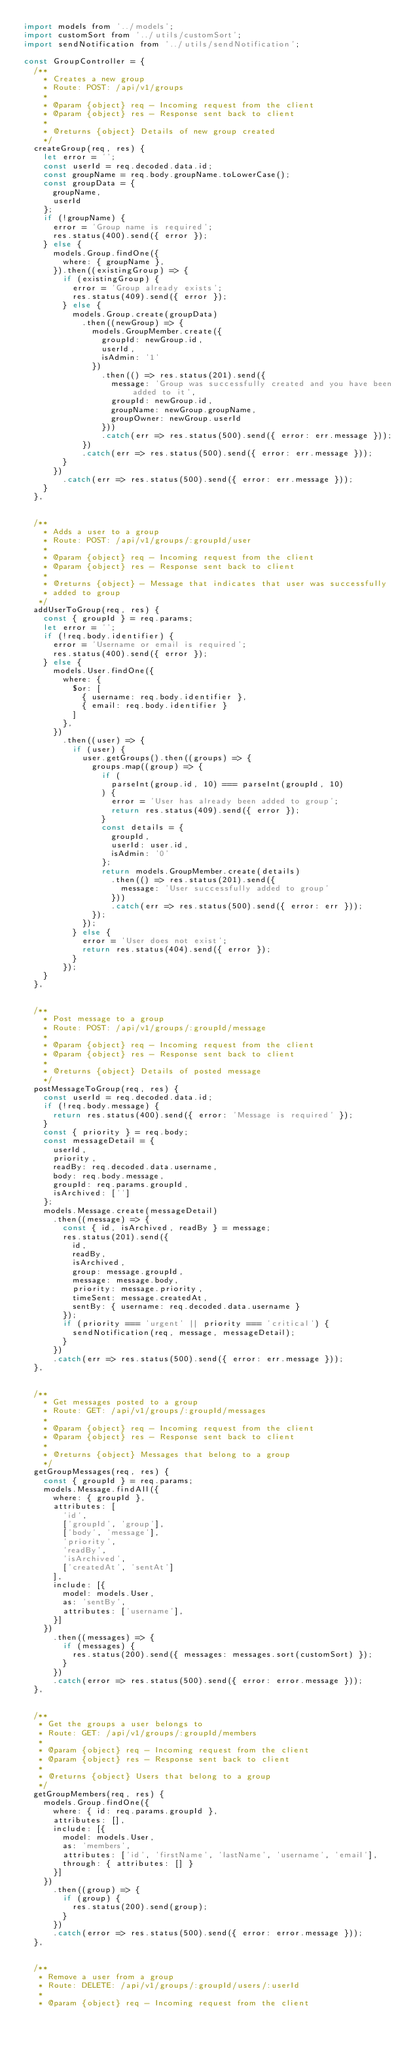<code> <loc_0><loc_0><loc_500><loc_500><_JavaScript_>import models from '../models';
import customSort from '../utils/customSort';
import sendNotification from '../utils/sendNotification';

const GroupController = {
  /**
    * Creates a new group
    * Route: POST: /api/v1/groups
    *
    * @param {object} req - Incoming request from the client
    * @param {object} res - Response sent back to client
    *
    * @returns {object} Details of new group created
    */
  createGroup(req, res) {
    let error = '';
    const userId = req.decoded.data.id;
    const groupName = req.body.groupName.toLowerCase();
    const groupData = {
      groupName,
      userId
    };
    if (!groupName) {
      error = 'Group name is required';
      res.status(400).send({ error });
    } else {
      models.Group.findOne({
        where: { groupName },
      }).then((existingGroup) => {
        if (existingGroup) {
          error = 'Group already exists';
          res.status(409).send({ error });
        } else {
          models.Group.create(groupData)
            .then((newGroup) => {
              models.GroupMember.create({
                groupId: newGroup.id,
                userId,
                isAdmin: '1'
              })
                .then(() => res.status(201).send({
                  message: 'Group was successfully created and you have been added to it',
                  groupId: newGroup.id,
                  groupName: newGroup.groupName,
                  groupOwner: newGroup.userId
                }))
                .catch(err => res.status(500).send({ error: err.message }));
            })
            .catch(err => res.status(500).send({ error: err.message }));
        }
      })
        .catch(err => res.status(500).send({ error: err.message }));
    }
  },


  /**
    * Adds a user to a group
    * Route: POST: /api/v1/groups/:groupId/user
    *
    * @param {object} req - Incoming request from the client
    * @param {object} res - Response sent back to client
    *
    * @returns {object} - Message that indicates that user was successfully
    * added to group
   */
  addUserToGroup(req, res) {
    const { groupId } = req.params;
    let error = '';
    if (!req.body.identifier) {
      error = 'Username or email is required';
      res.status(400).send({ error });
    } else {
      models.User.findOne({
        where: {
          $or: [
            { username: req.body.identifier },
            { email: req.body.identifier }
          ]
        },
      })
        .then((user) => {
          if (user) {
            user.getGroups().then((groups) => {
              groups.map((group) => {
                if (
                  parseInt(group.id, 10) === parseInt(groupId, 10)
                ) {
                  error = 'User has already been added to group';
                  return res.status(409).send({ error });
                }
                const details = {
                  groupId,
                  userId: user.id,
                  isAdmin: '0'
                };
                return models.GroupMember.create(details)
                  .then(() => res.status(201).send({
                    message: 'User successfully added to group'
                  }))
                  .catch(err => res.status(500).send({ error: err }));
              });
            });
          } else {
            error = 'User does not exist';
            return res.status(404).send({ error });
          }
        });
    }
  },


  /**
    * Post message to a group
    * Route: POST: /api/v1/groups/:groupId/message
    *
    * @param {object} req - Incoming request from the client
    * @param {object} res - Response sent back to client
    *
    * @returns {object} Details of posted message
    */
  postMessageToGroup(req, res) {
    const userId = req.decoded.data.id;
    if (!req.body.message) {
      return res.status(400).send({ error: 'Message is required' });
    }
    const { priority } = req.body;
    const messageDetail = {
      userId,
      priority,
      readBy: req.decoded.data.username,
      body: req.body.message,
      groupId: req.params.groupId,
      isArchived: ['']
    };
    models.Message.create(messageDetail)
      .then((message) => {
        const { id, isArchived, readBy } = message;
        res.status(201).send({
          id,
          readBy,
          isArchived,
          group: message.groupId,
          message: message.body,
          priority: message.priority,
          timeSent: message.createdAt,
          sentBy: { username: req.decoded.data.username }
        });
        if (priority === 'urgent' || priority === 'critical') {
          sendNotification(req, message, messageDetail);
        }
      })
      .catch(err => res.status(500).send({ error: err.message }));
  },


  /**
    * Get messages posted to a group
    * Route: GET: /api/v1/groups/:groupId/messages
    *
    * @param {object} req - Incoming request from the client
    * @param {object} res - Response sent back to client
    *
    * @returns {object} Messages that belong to a group
    */
  getGroupMessages(req, res) {
    const { groupId } = req.params;
    models.Message.findAll({
      where: { groupId },
      attributes: [
        'id',
        ['groupId', 'group'],
        ['body', 'message'],
        'priority',
        'readBy',
        'isArchived',
        ['createdAt', 'sentAt']
      ],
      include: [{
        model: models.User,
        as: 'sentBy',
        attributes: ['username'],
      }]
    })
      .then((messages) => {
        if (messages) {
          res.status(200).send({ messages: messages.sort(customSort) });
        }
      })
      .catch(error => res.status(500).send({ error: error.message }));
  },


  /**
   * Get the groups a user belongs to
   * Route: GET: /api/v1/groups/:groupId/members
   *
   * @param {object} req - Incoming request from the client
   * @param {object} res - Response sent back to client
   *
   * @returns {object} Users that belong to a group
   */
  getGroupMembers(req, res) {
    models.Group.findOne({
      where: { id: req.params.groupId },
      attributes: [],
      include: [{
        model: models.User,
        as: 'members',
        attributes: ['id', 'firstName', 'lastName', 'username', 'email'],
        through: { attributes: [] }
      }]
    })
      .then((group) => {
        if (group) {
          res.status(200).send(group);
        }
      })
      .catch(error => res.status(500).send({ error: error.message }));
  },


  /**
   * Remove a user from a group
   * Route: DELETE: /api/v1/groups/:groupId/users/:userId
   *
   * @param {object} req - Incoming request from the client</code> 